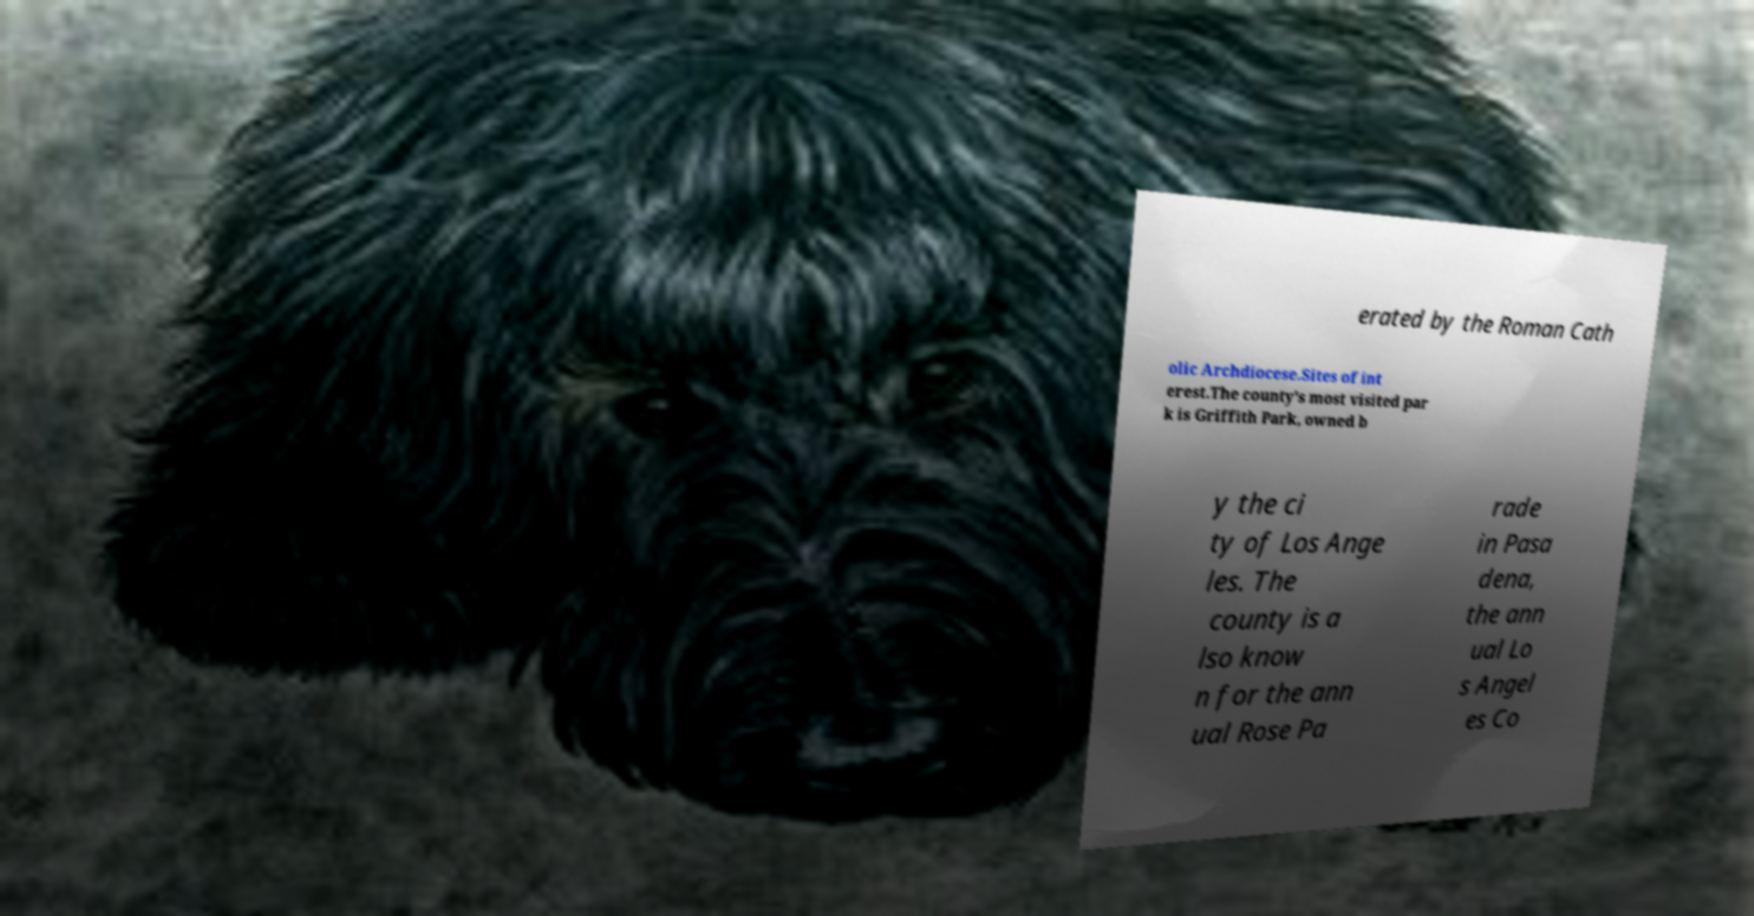Could you assist in decoding the text presented in this image and type it out clearly? erated by the Roman Cath olic Archdiocese.Sites of int erest.The county's most visited par k is Griffith Park, owned b y the ci ty of Los Ange les. The county is a lso know n for the ann ual Rose Pa rade in Pasa dena, the ann ual Lo s Angel es Co 